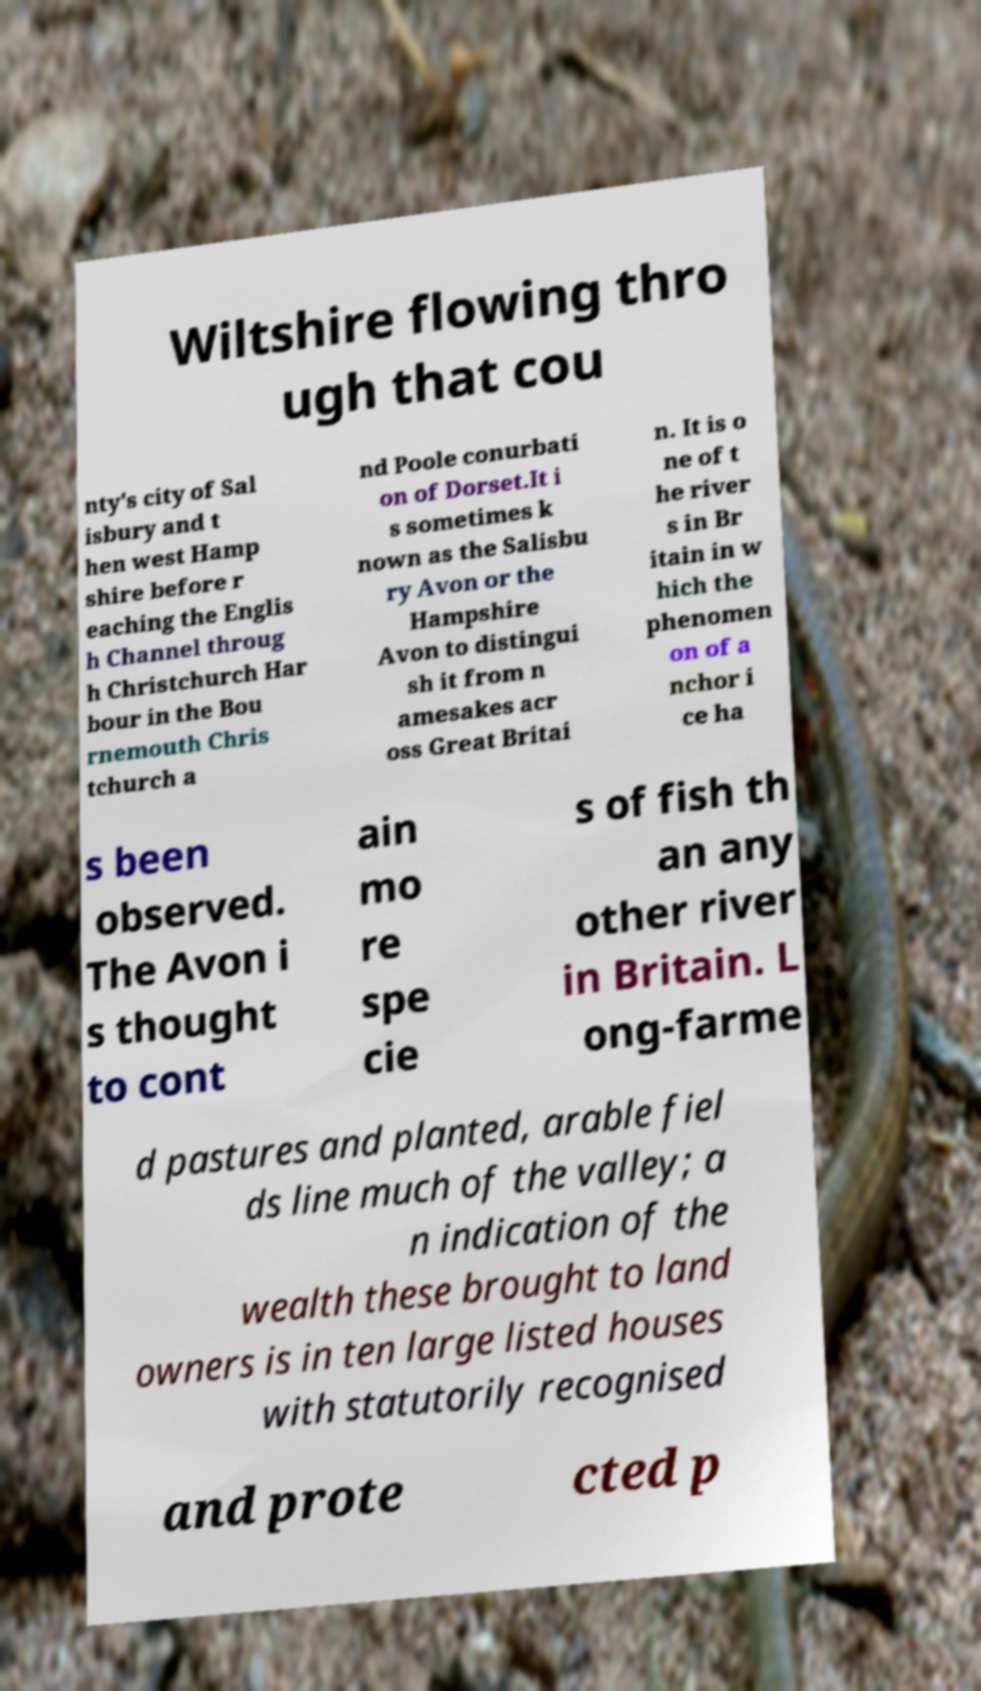Can you accurately transcribe the text from the provided image for me? Wiltshire flowing thro ugh that cou nty's city of Sal isbury and t hen west Hamp shire before r eaching the Englis h Channel throug h Christchurch Har bour in the Bou rnemouth Chris tchurch a nd Poole conurbati on of Dorset.It i s sometimes k nown as the Salisbu ry Avon or the Hampshire Avon to distingui sh it from n amesakes acr oss Great Britai n. It is o ne of t he river s in Br itain in w hich the phenomen on of a nchor i ce ha s been observed. The Avon i s thought to cont ain mo re spe cie s of fish th an any other river in Britain. L ong-farme d pastures and planted, arable fiel ds line much of the valley; a n indication of the wealth these brought to land owners is in ten large listed houses with statutorily recognised and prote cted p 